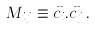Convert formula to latex. <formula><loc_0><loc_0><loc_500><loc_500>M _ { i j } \equiv \vec { c } _ { i } . \vec { c } _ { j } \, .</formula> 